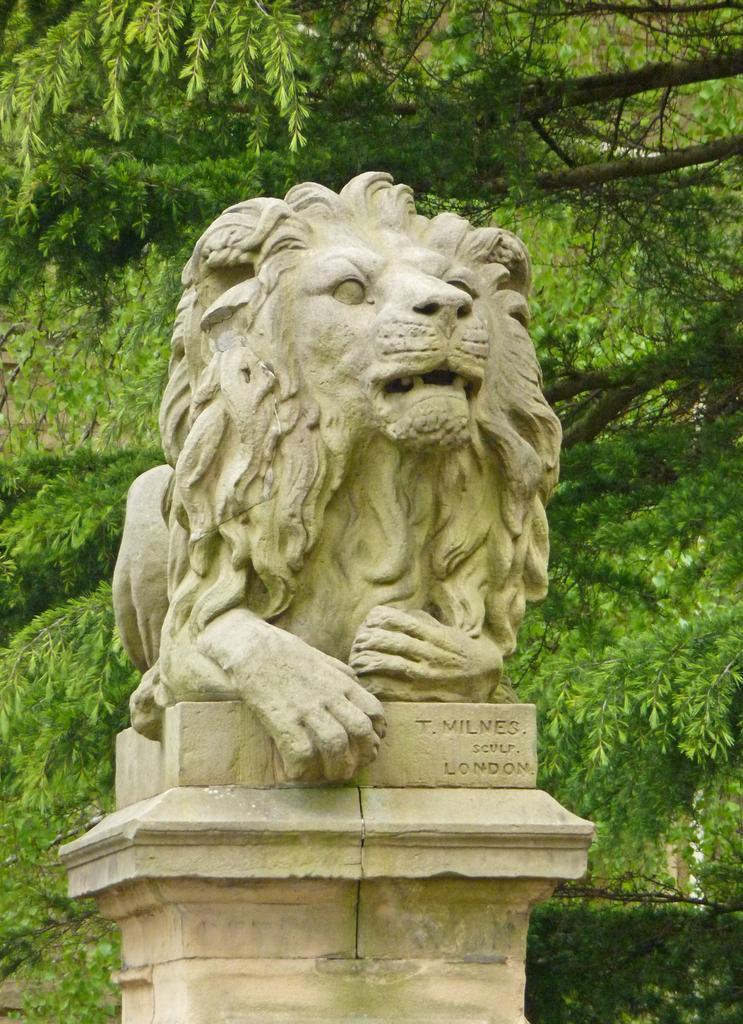In one or two sentences, can you explain what this image depicts? In this image we can see statue of an animal on a pedestal. In the background there are trees. 